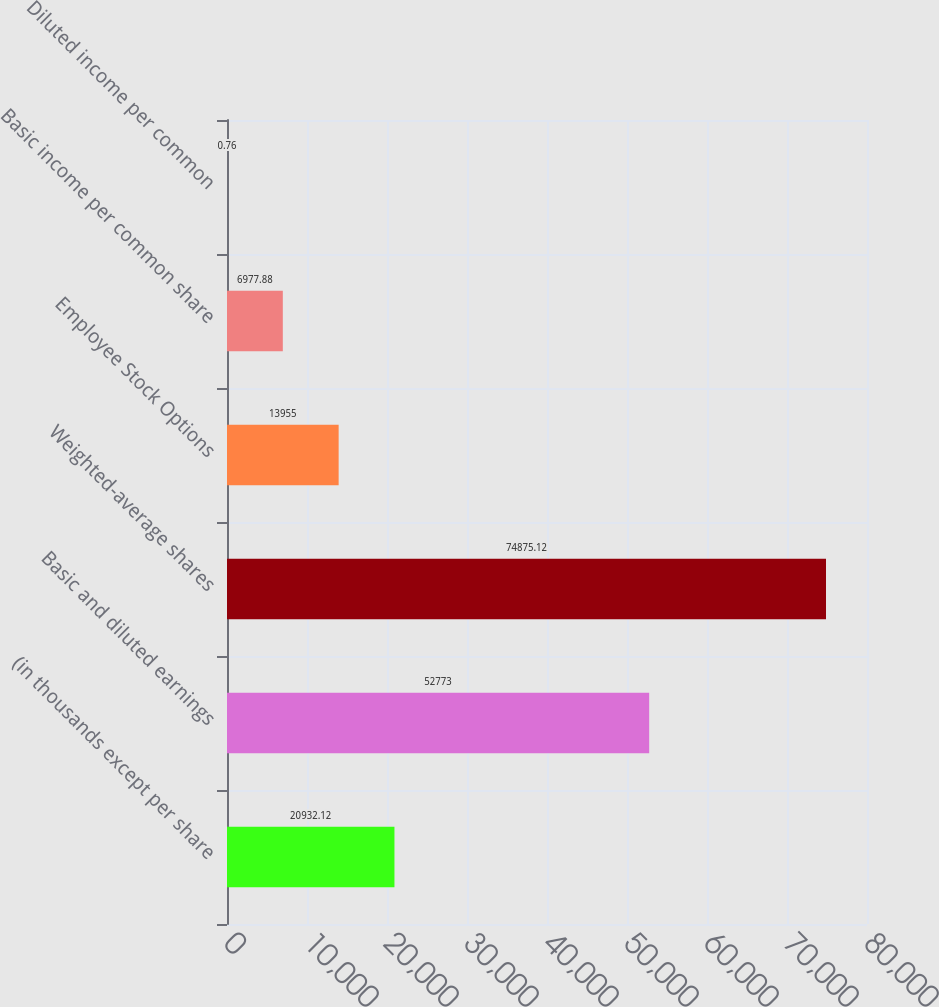Convert chart. <chart><loc_0><loc_0><loc_500><loc_500><bar_chart><fcel>(in thousands except per share<fcel>Basic and diluted earnings<fcel>Weighted-average shares<fcel>Employee Stock Options<fcel>Basic income per common share<fcel>Diluted income per common<nl><fcel>20932.1<fcel>52773<fcel>74875.1<fcel>13955<fcel>6977.88<fcel>0.76<nl></chart> 